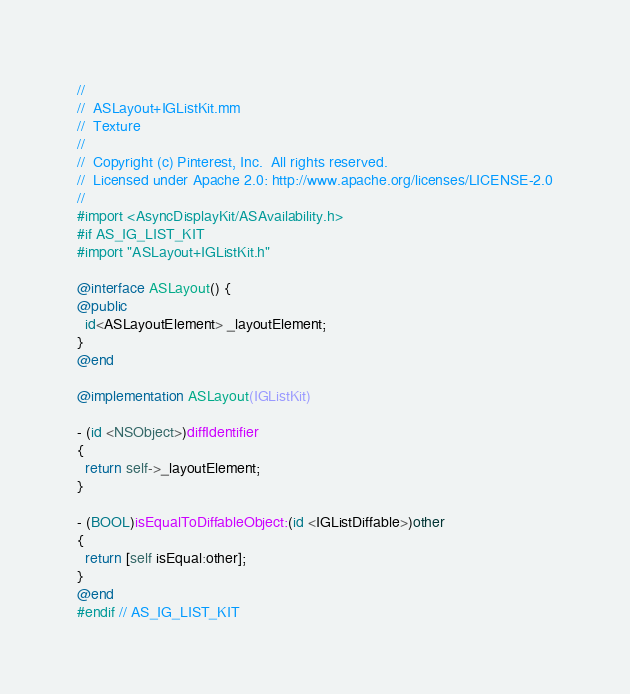Convert code to text. <code><loc_0><loc_0><loc_500><loc_500><_ObjectiveC_>//
//  ASLayout+IGListKit.mm
//  Texture
//
//  Copyright (c) Pinterest, Inc.  All rights reserved.
//  Licensed under Apache 2.0: http://www.apache.org/licenses/LICENSE-2.0
//
#import <AsyncDisplayKit/ASAvailability.h>
#if AS_IG_LIST_KIT
#import "ASLayout+IGListKit.h"

@interface ASLayout() {
@public
  id<ASLayoutElement> _layoutElement;
}
@end

@implementation ASLayout(IGListKit)

- (id <NSObject>)diffIdentifier
{
  return self->_layoutElement;
}

- (BOOL)isEqualToDiffableObject:(id <IGListDiffable>)other
{
  return [self isEqual:other];
}
@end
#endif // AS_IG_LIST_KIT
</code> 